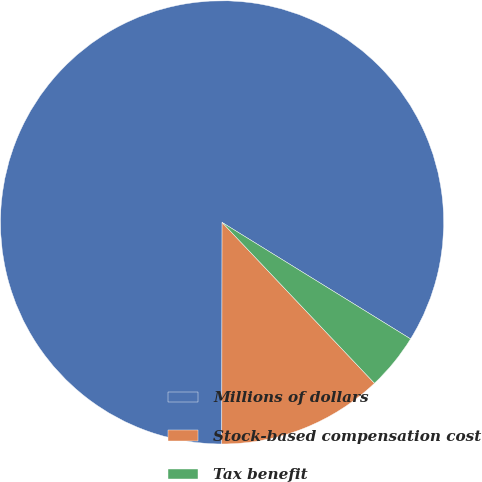Convert chart to OTSL. <chart><loc_0><loc_0><loc_500><loc_500><pie_chart><fcel>Millions of dollars<fcel>Stock-based compensation cost<fcel>Tax benefit<nl><fcel>83.8%<fcel>12.09%<fcel>4.12%<nl></chart> 